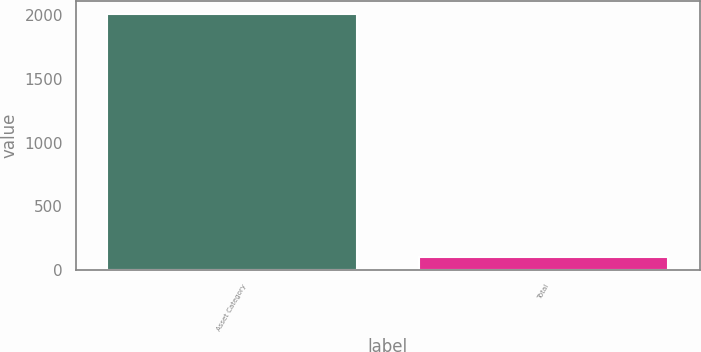Convert chart. <chart><loc_0><loc_0><loc_500><loc_500><bar_chart><fcel>Asset Category<fcel>Total<nl><fcel>2014<fcel>100<nl></chart> 